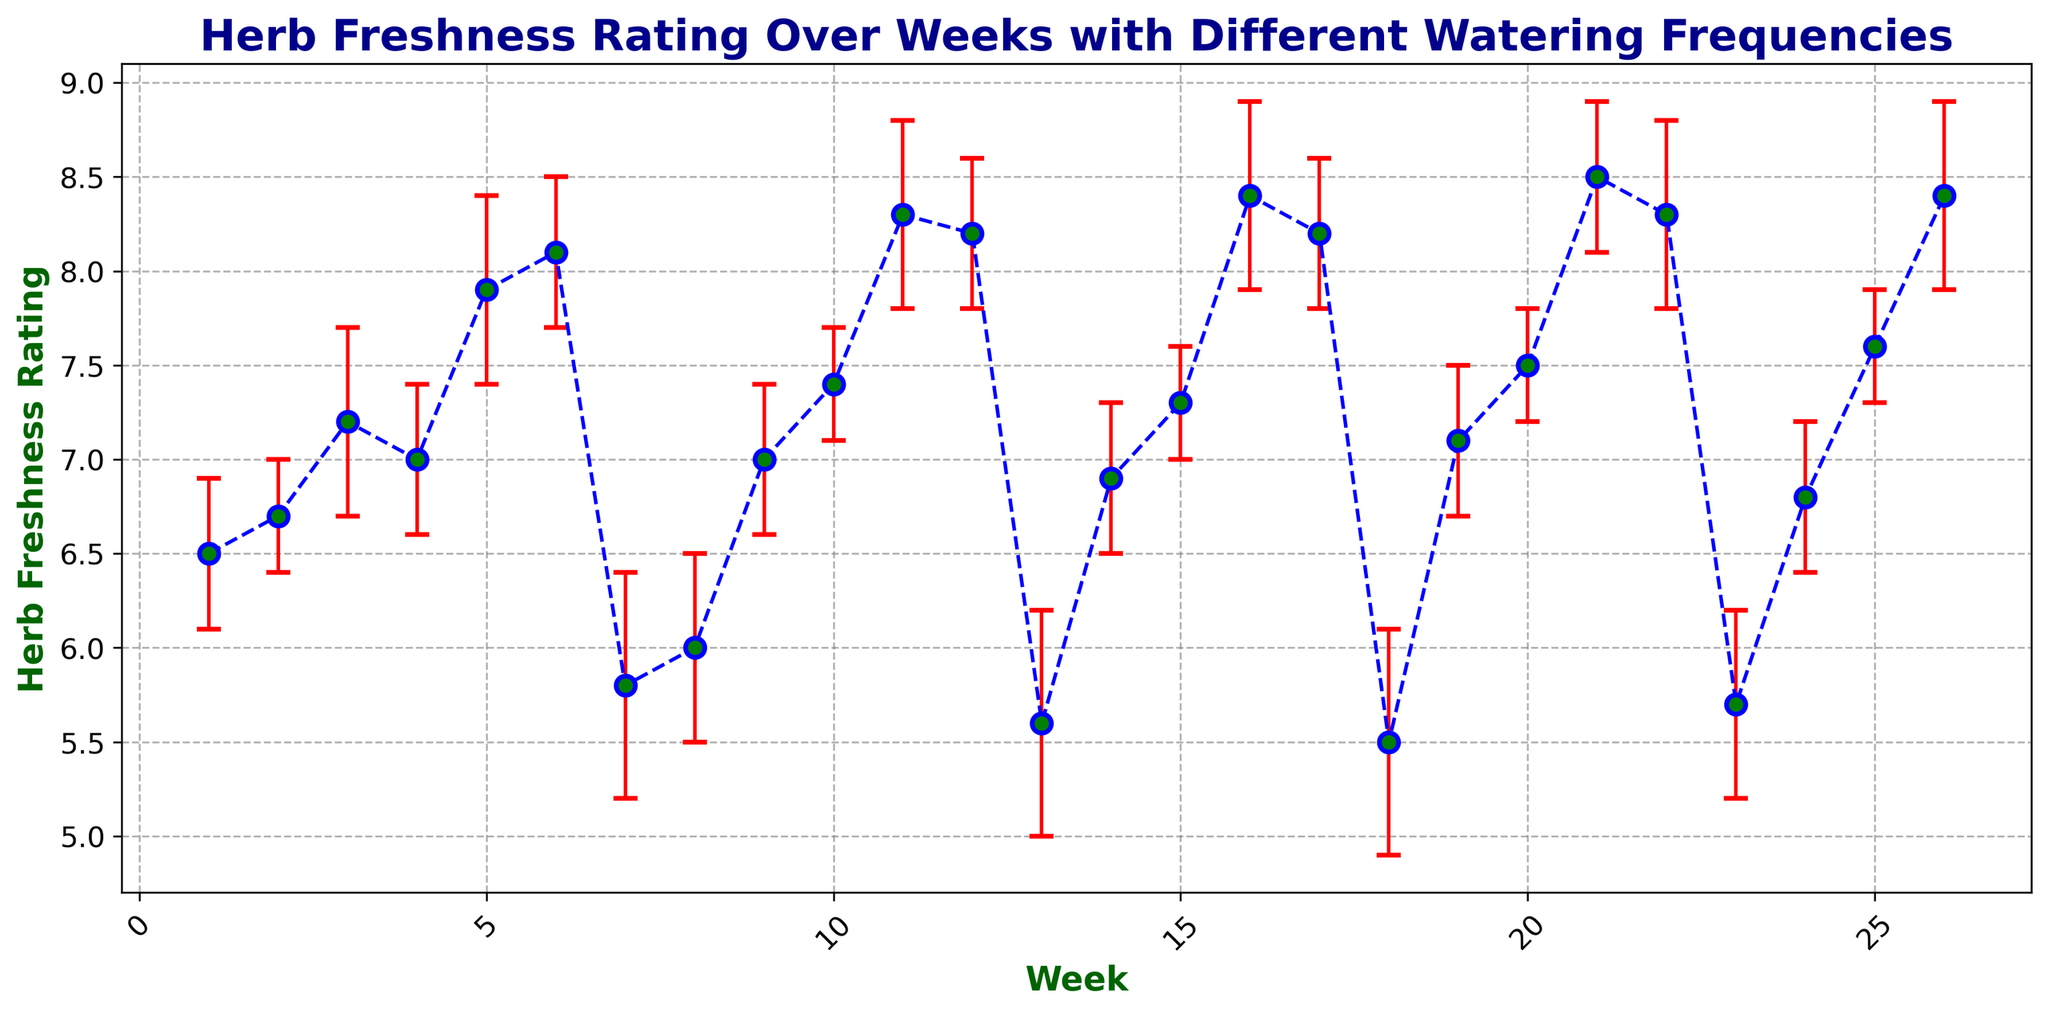What's the range of herb freshness ratings over the 26 weeks? The highest herb freshness rating is 8.5 and the lowest is 5.5. Range is calculated as the difference between these values: 8.5 - 5.5 = 3
Answer: 3 Which week has the highest herb freshness rating? The highest herb freshness rating of 8.5 occurs during Week 21
Answer: Week 21 On average, how does a watering frequency of 5 days/week affect herb freshness ratings compared to a frequency of 2 days/week? Calculate the average rating for a frequency of 5 days/week: (7.9+8.1+8.3+8.2+8.4+8.5+8.3+8.4) / 8 = 8.14. For 2 days/week: (5.8+6.0+5.6+5.5+5.7) / 5 = 5.72. Compare the two averages: 8.14 is higher than 5.72
Answer: Higher Are there any weeks with the same error estimate for herb freshness ratings? Scan for repeated error estimate values (0.4, 0.3, 0.5, 0.6). Week pairs that share the same error estimate include Weeks 1, 3, 8, 10, 13, 19, 24 with error 0.4; Weeks 4, 6, 11, 12, 16, 17, 22 with error 0.5, etc
Answer: Yes Which weeks had the most consistent herb freshness ratings and what was the common error estimate? The smallest error estimate represents the most consistent ratings. Weeks with error estimate of 0.3 were Weeks 2, 10, 15, 20, 25
Answer: Weeks 2, 10, 15, 20, 25 with error 0.3 During which weeks was the watering frequency 4 days/week and what were the corresponding herb freshness ratings? Extract weeks with watering frequency of 4 days/week: Week 3 (7.2), Week 4 (7.0), Week 10 (7.4), Week 15 (7.3), and Week 20 (7.5), Week 25 (7.6)
Answer: Weeks 3, 4, 10, 15, 20, 25 with ratings 7.2, 7.0, 7.4, 7.3, 7.5, 7.6 In which weeks does the herb freshness rating lie between 6.0 and 7.0, and what is the corresponding watering frequency? Scan to find ratings between 6.0 and 7.0: Week 2 (6.7), Week 1 (6.5), Week 14 (6.9), Week 24 (6.8), Week 7 (5.8), Week 8 (6.0) with frequencies of 3, 3, 3, 3, 2, 2 respectively
Answer: Weeks 1, 2, 7, 8, 14, 24 with frequencies 3, 3, 2, 2, 3, 3 How many times does the herb freshness rating exceed 8 with a watering frequency of 5 days/week? Count occurrences where freshness rating > 8 for 5 days/week: Weeks 6 (8.1), Week 11 (8.3), Week 16 (8.4), Week 21 (8.5), Week 22 (8.3), Week 26 (8.4) = 6 times
Answer: 6 times 